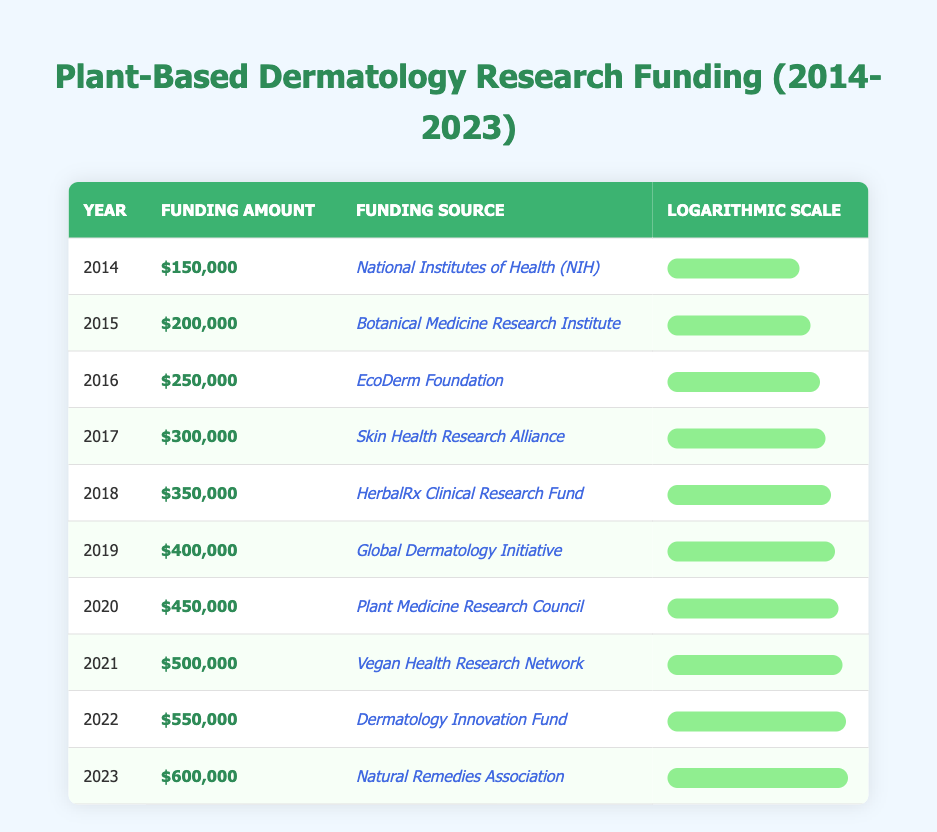What was the funding amount from the EcoDerm Foundation in 2016? Referring to the table, in 2016, the funding amount from the EcoDerm Foundation is listed as $250,000.
Answer: $250,000 Which year had the highest funding allocation for plant-based dermatology studies? By examining the table, the highest funding allocation for plant-based dermatology studies occurred in 2023, with a funding amount of $600,000.
Answer: 2023 What is the total funding received from 2014 to 2018? To calculate the total funding from 2014 to 2018, we sum the amounts: $150,000 (2014) + $200,000 (2015) + $250,000 (2016) + $300,000 (2017) + $350,000 (2018) = $1,250,000.
Answer: $1,250,000 Did the funding amount increase every year from 2014 to 2023? Observing the table, each year from 2014 to 2023 shows an increase in funding, confirming that the funding increased every year.
Answer: Yes What was the average funding amount for the years 2020 to 2022? The funding amounts for 2020 to 2022 are $450,000 (2020), $500,000 (2021), and $550,000 (2022). The total is $450,000 + $500,000 + $550,000 = $1,500,000, and there are 3 years, so the average is $1,500,000 / 3 = $500,000.
Answer: $500,000 How much did the funding amount increase from 2019 to 2023? The funding amount in 2019 was $400,000, and in 2023 it was $600,000. The increase is $600,000 - $400,000 = $200,000.
Answer: $200,000 Which funding source provided $500,000 in 2021? According to the table, the Vegan Health Research Network provided $500,000 in 2021.
Answer: Vegan Health Research Network Was the funding from the Natural Remedies Association the highest in 2023? The table indicates that $600,000 was funded by the Natural Remedies Association in 2023, and since it is the largest value listed for that year, this statement is true.
Answer: Yes 